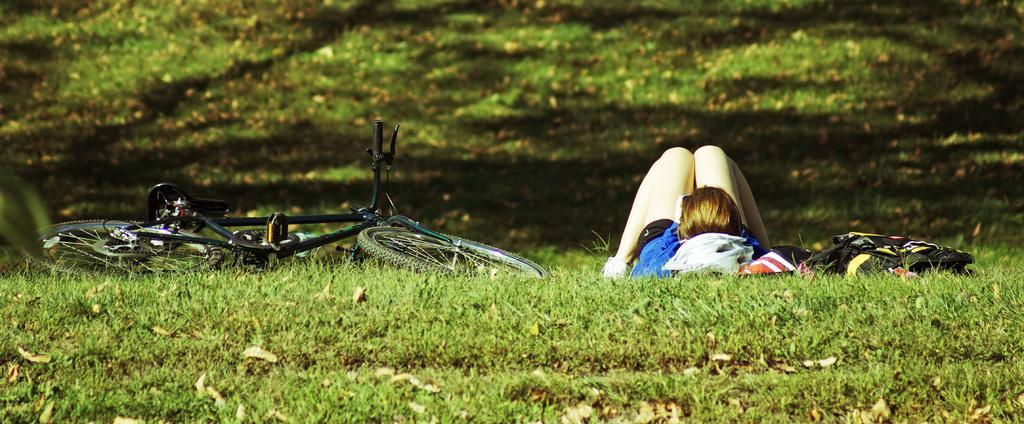Could you give a brief overview of what you see in this image? This image consists of a girl lying on the ground. At the bottom, there is green grass on the ground. To the left, there is a bicycle. To the right, there is a bag. In the background, there is green grass on the ground. 